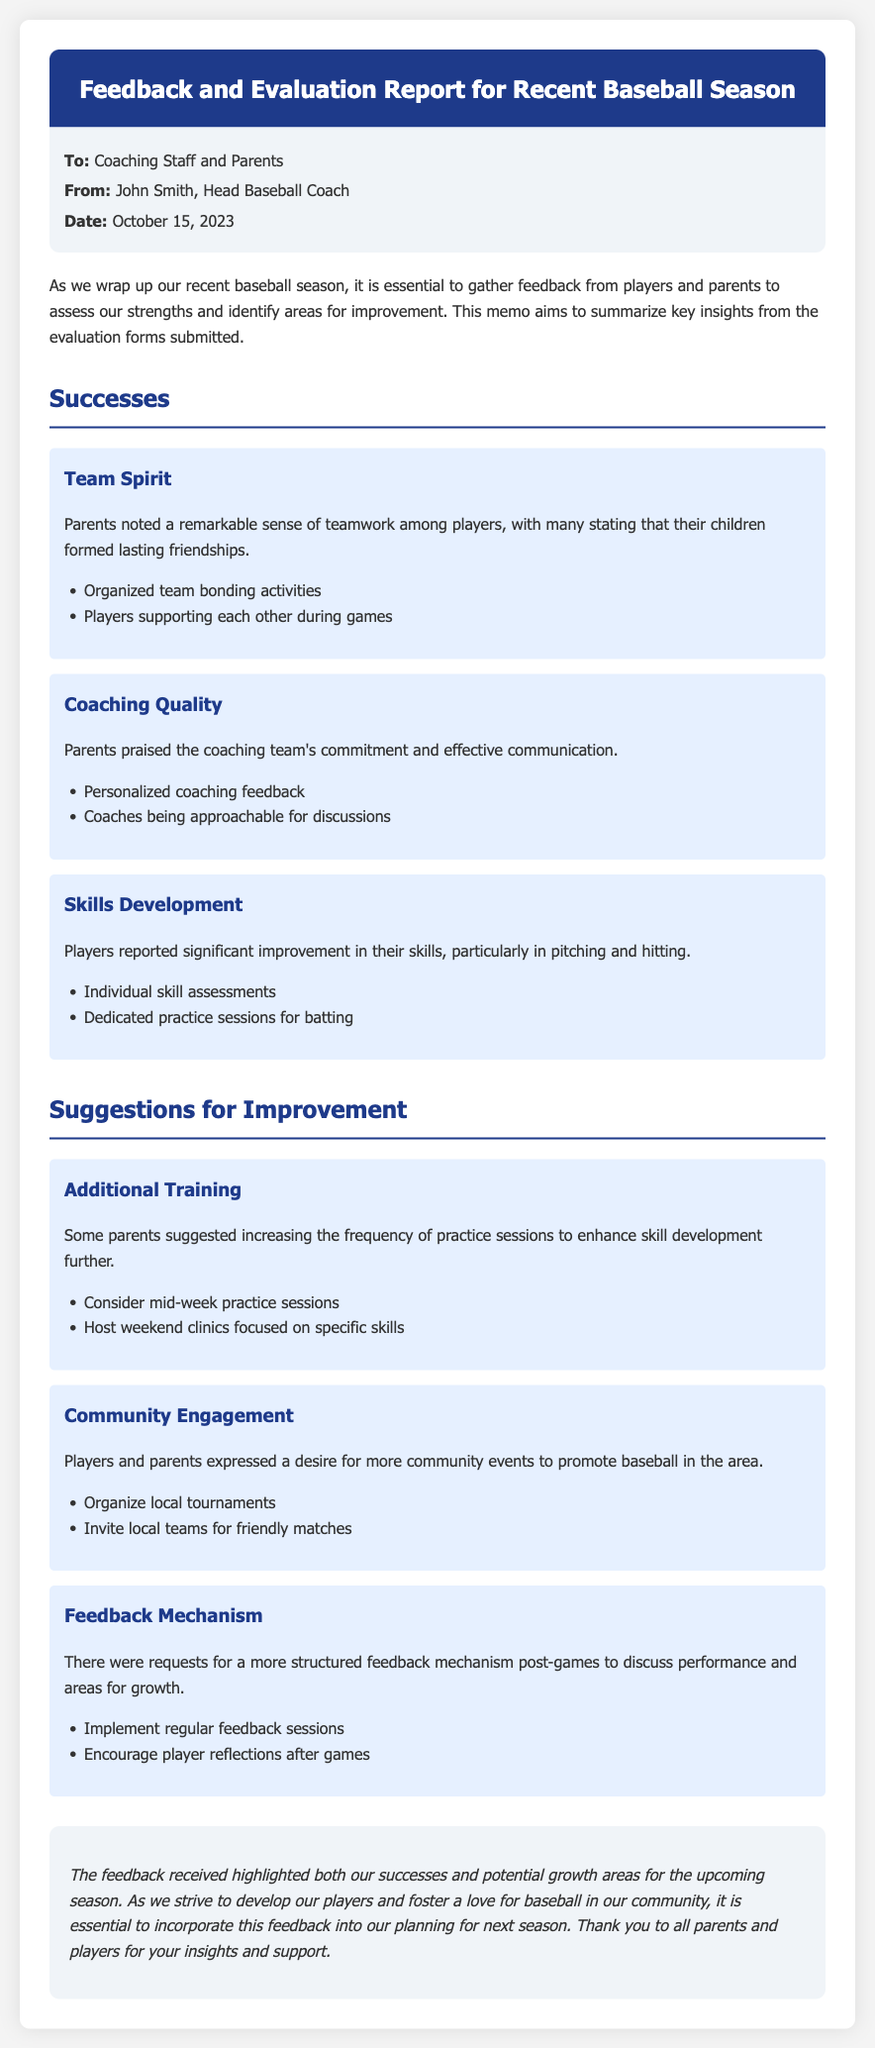What is the date of the memo? The date of the memo is found in the metadata section, which states October 15, 2023.
Answer: October 15, 2023 Who is the author of the memo? The memo clearly identifies John Smith as the Head Baseball Coach in the metadata section.
Answer: John Smith What aspect of teamwork was noted as a success? The successes include remarks on teamwork in the section about "Team Spirit," particularly that players formed lasting friendships.
Answer: Lasting friendships What was suggested regarding practice sessions? The section on suggestions for improvement points out the need for additional training with specific mentions of increasing practice session frequency.
Answer: Increase frequency What mechanism was requested for post-game feedback? The feedback section highlights a request for a more structured feedback mechanism post-games for performance discussion.
Answer: Structured feedback mechanism How were players' skills reported to have improved? The skills development subsection indicates that players reported significant improvement specifically in pitching and hitting.
Answer: Pitching and hitting What is the main purpose of the memo? The memo aims to summarize key insights from evaluation forms submitted to assess strengths and identify areas for improvement in this baseball season.
Answer: Assess strengths and identify areas for improvement Which community engagement activity was suggested? The suggestions for improving community engagement included organizing local tournaments to promote baseball.
Answer: Organizing local tournaments 